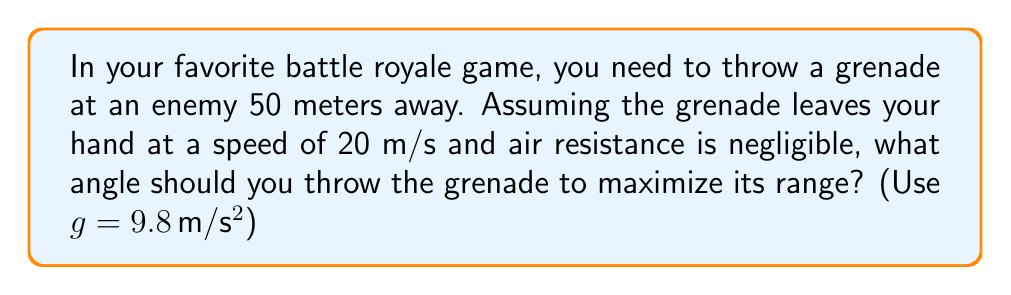What is the answer to this math problem? Let's approach this step-by-step:

1) The range of a projectile in ideal conditions is given by the equation:

   $$R = \frac{v^2 \sin(2\theta)}{g}$$

   Where R is the range, v is the initial velocity, θ is the launch angle, and g is the acceleration due to gravity.

2) To find the maximum range, we need to maximize $\sin(2\theta)$. This function reaches its maximum value of 1 when $2\theta = 90°$ or $\theta = 45°$.

3) We can verify this by calculating the range for θ = 45°:

   $$R = \frac{(20 \text{ m/s})^2 \sin(2 * 45°)}{9.8 \text{ m/s}^2}$$
   
   $$R = \frac{400 \text{ m}^2 * 1}{9.8 \text{ m/s}^2} = 40.82 \text{ m}$$

4) This is indeed the maximum range for the given initial velocity. However, our target is at 50 m, which is beyond this maximum range.

5) In a game scenario, this means you'd need to aim directly at the target (i.e., use a smaller angle) to hit them, as the maximum range falls short of the target distance.

6) The optimal angle for hitting a target that's within the maximum range but not at the maximum range would be found using the equation:

   $$\theta = \frac{1}{2}\arcsin(\frac{gR}{v^2})$$

   But in this case, since the target is beyond the maximum range, the optimal angle is the one that gives the maximum range, which is 45°.
Answer: 45° 